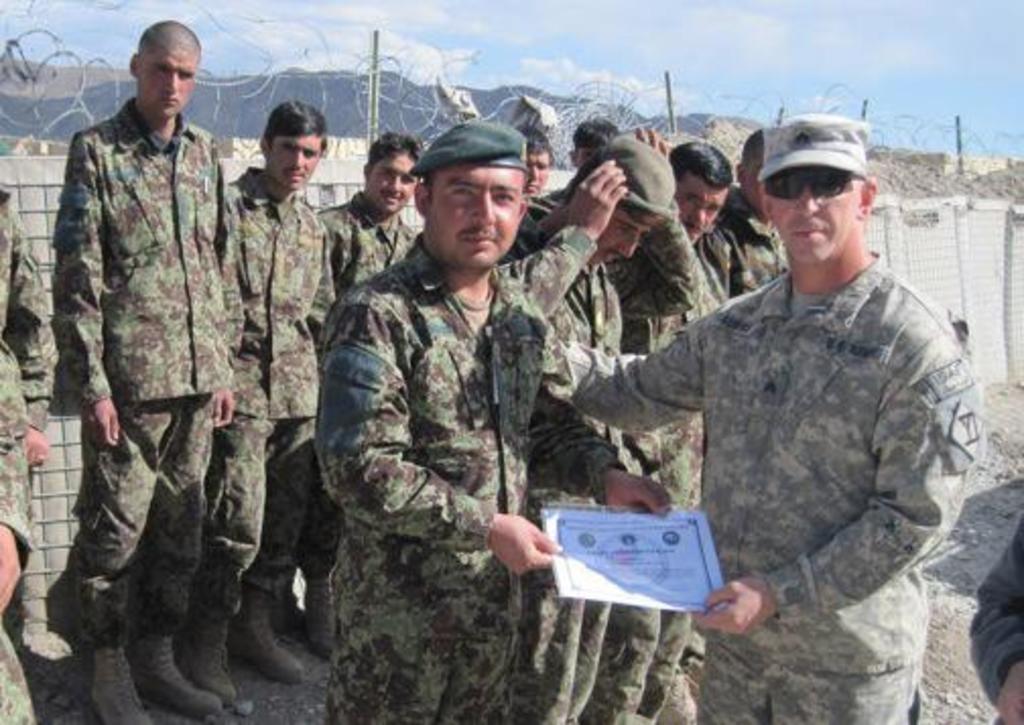Could you give a brief overview of what you see in this image? In this image, we can see two people holding certificate in their hands. In the background, there are some people and we can see a fence. 